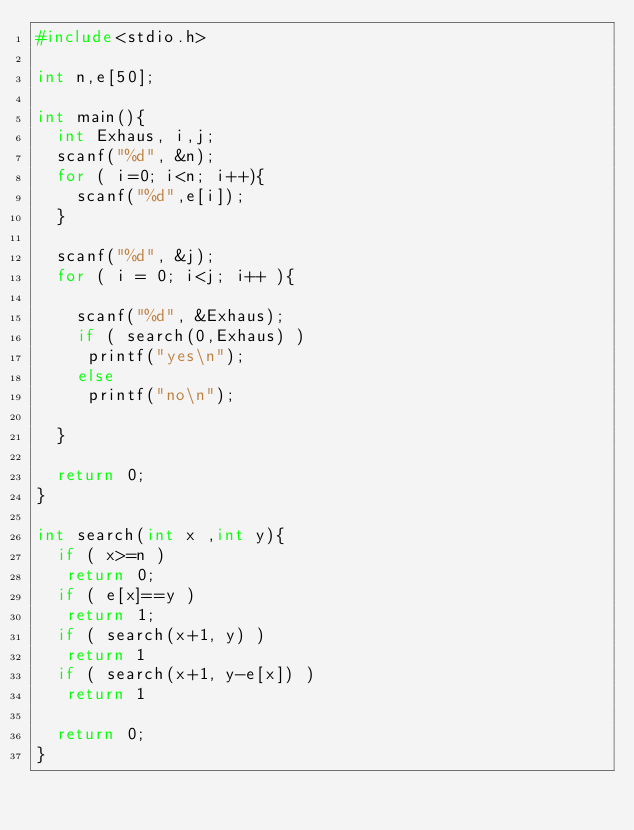<code> <loc_0><loc_0><loc_500><loc_500><_C_>#include<stdio.h>

int n,e[50];

int main(){
  int Exhaus, i,j;
  scanf("%d", &n);
  for ( i=0; i<n; i++){
    scanf("%d",e[i]);
  }

  scanf("%d", &j);
  for ( i = 0; i<j; i++ ){

    scanf("%d", &Exhaus);
    if ( search(0,Exhaus) )
     printf("yes\n");
    else 
     printf("no\n");

  }

  return 0;
}

int search(int x ,int y){
  if ( x>=n )
   return 0;
  if ( e[x]==y )
   return 1;
  if ( search(x+1, y) ) 
   return 1
  if ( search(x+1, y-e[x]) )
   return 1

  return 0;
}
</code> 